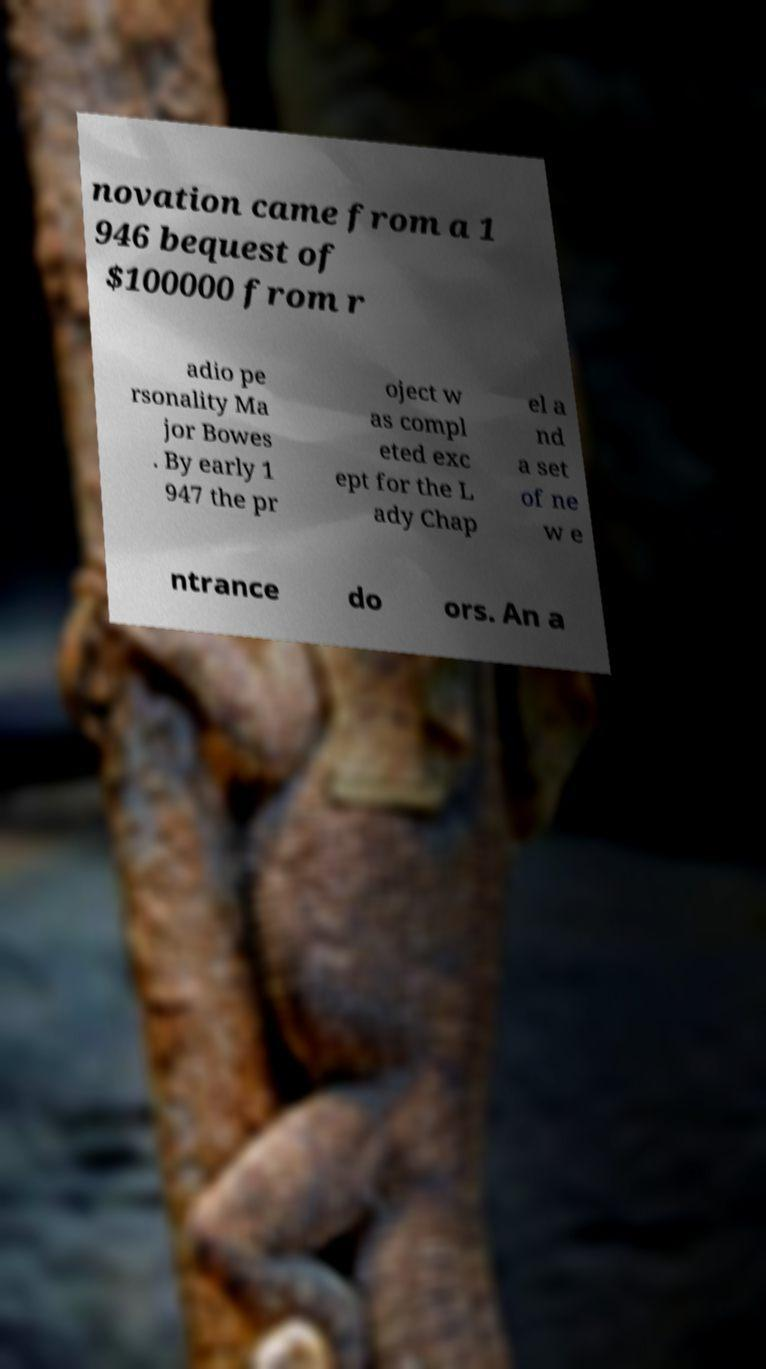Can you accurately transcribe the text from the provided image for me? novation came from a 1 946 bequest of $100000 from r adio pe rsonality Ma jor Bowes . By early 1 947 the pr oject w as compl eted exc ept for the L ady Chap el a nd a set of ne w e ntrance do ors. An a 